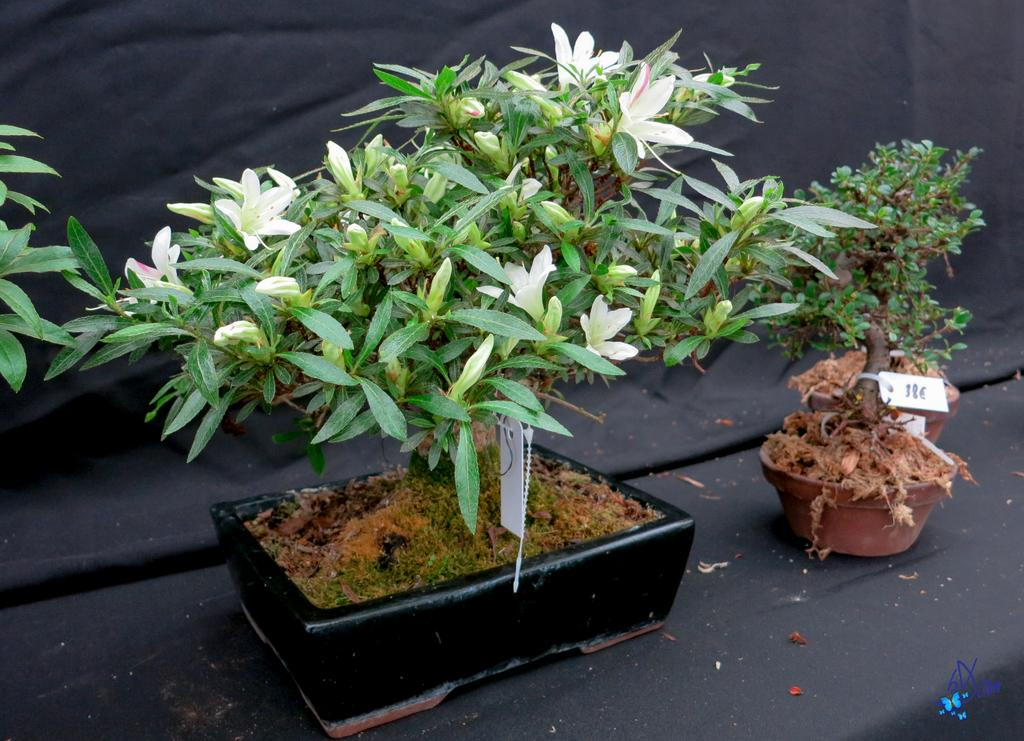What is located in the middle of the image? There are plants in the middle of the image. What can be seen attached to the plants? There are tags on the plants. What type of material is visible behind the plants? There is cloth visible behind the plants. What language is the plant crying in the image? Plants do not have the ability to cry or communicate in a language, so this question cannot be answered. 